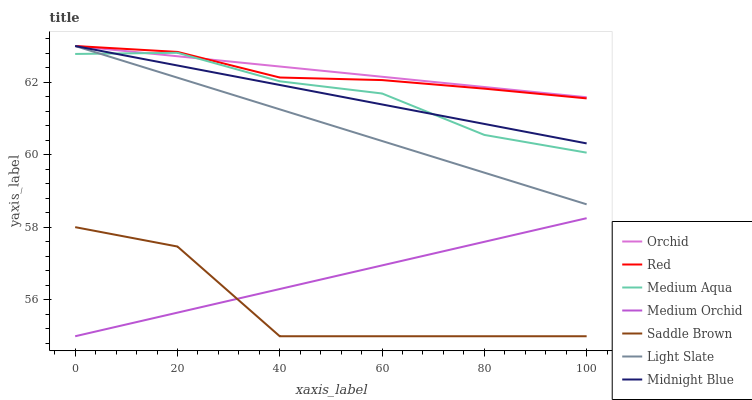Does Saddle Brown have the minimum area under the curve?
Answer yes or no. Yes. Does Orchid have the maximum area under the curve?
Answer yes or no. Yes. Does Light Slate have the minimum area under the curve?
Answer yes or no. No. Does Light Slate have the maximum area under the curve?
Answer yes or no. No. Is Midnight Blue the smoothest?
Answer yes or no. Yes. Is Saddle Brown the roughest?
Answer yes or no. Yes. Is Light Slate the smoothest?
Answer yes or no. No. Is Light Slate the roughest?
Answer yes or no. No. Does Medium Orchid have the lowest value?
Answer yes or no. Yes. Does Light Slate have the lowest value?
Answer yes or no. No. Does Orchid have the highest value?
Answer yes or no. Yes. Does Medium Orchid have the highest value?
Answer yes or no. No. Is Saddle Brown less than Orchid?
Answer yes or no. Yes. Is Medium Aqua greater than Medium Orchid?
Answer yes or no. Yes. Does Red intersect Midnight Blue?
Answer yes or no. Yes. Is Red less than Midnight Blue?
Answer yes or no. No. Is Red greater than Midnight Blue?
Answer yes or no. No. Does Saddle Brown intersect Orchid?
Answer yes or no. No. 